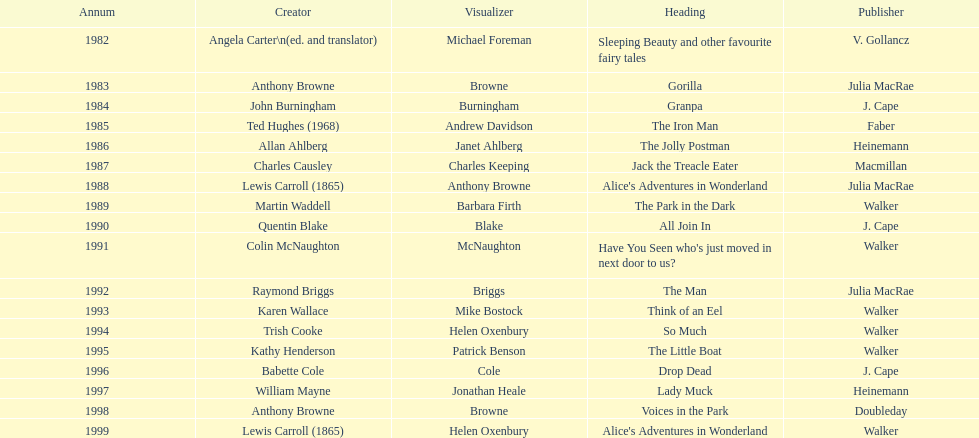How many number of titles are listed for the year 1991? 1. 